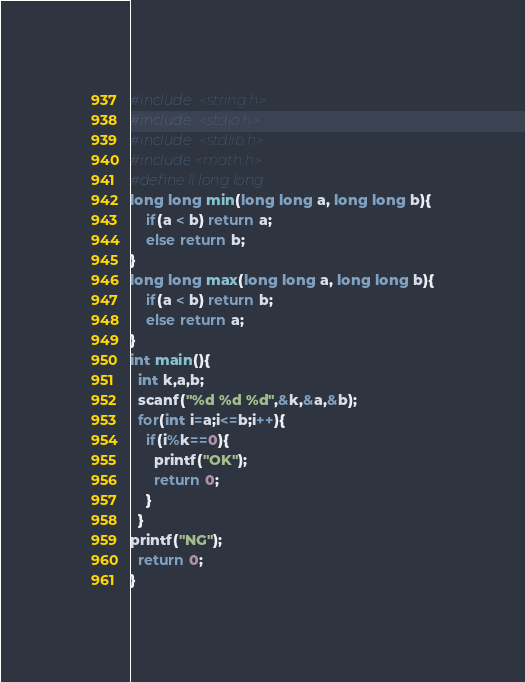<code> <loc_0><loc_0><loc_500><loc_500><_C_>#include <string.h>
#include <stdio.h>
#include <stdlib.h>
#include<math.h>
#define ll long long
long long min(long long a, long long b){
    if(a < b) return a;
    else return b;
}
long long max(long long a, long long b){
    if(a < b) return b;
    else return a;
}
int main(){
  int k,a,b;
  scanf("%d %d %d",&k,&a,&b);
  for(int i=a;i<=b;i++){
    if(i%k==0){
      printf("OK");
      return 0;
    }
  }
printf("NG");
  return 0;
}</code> 